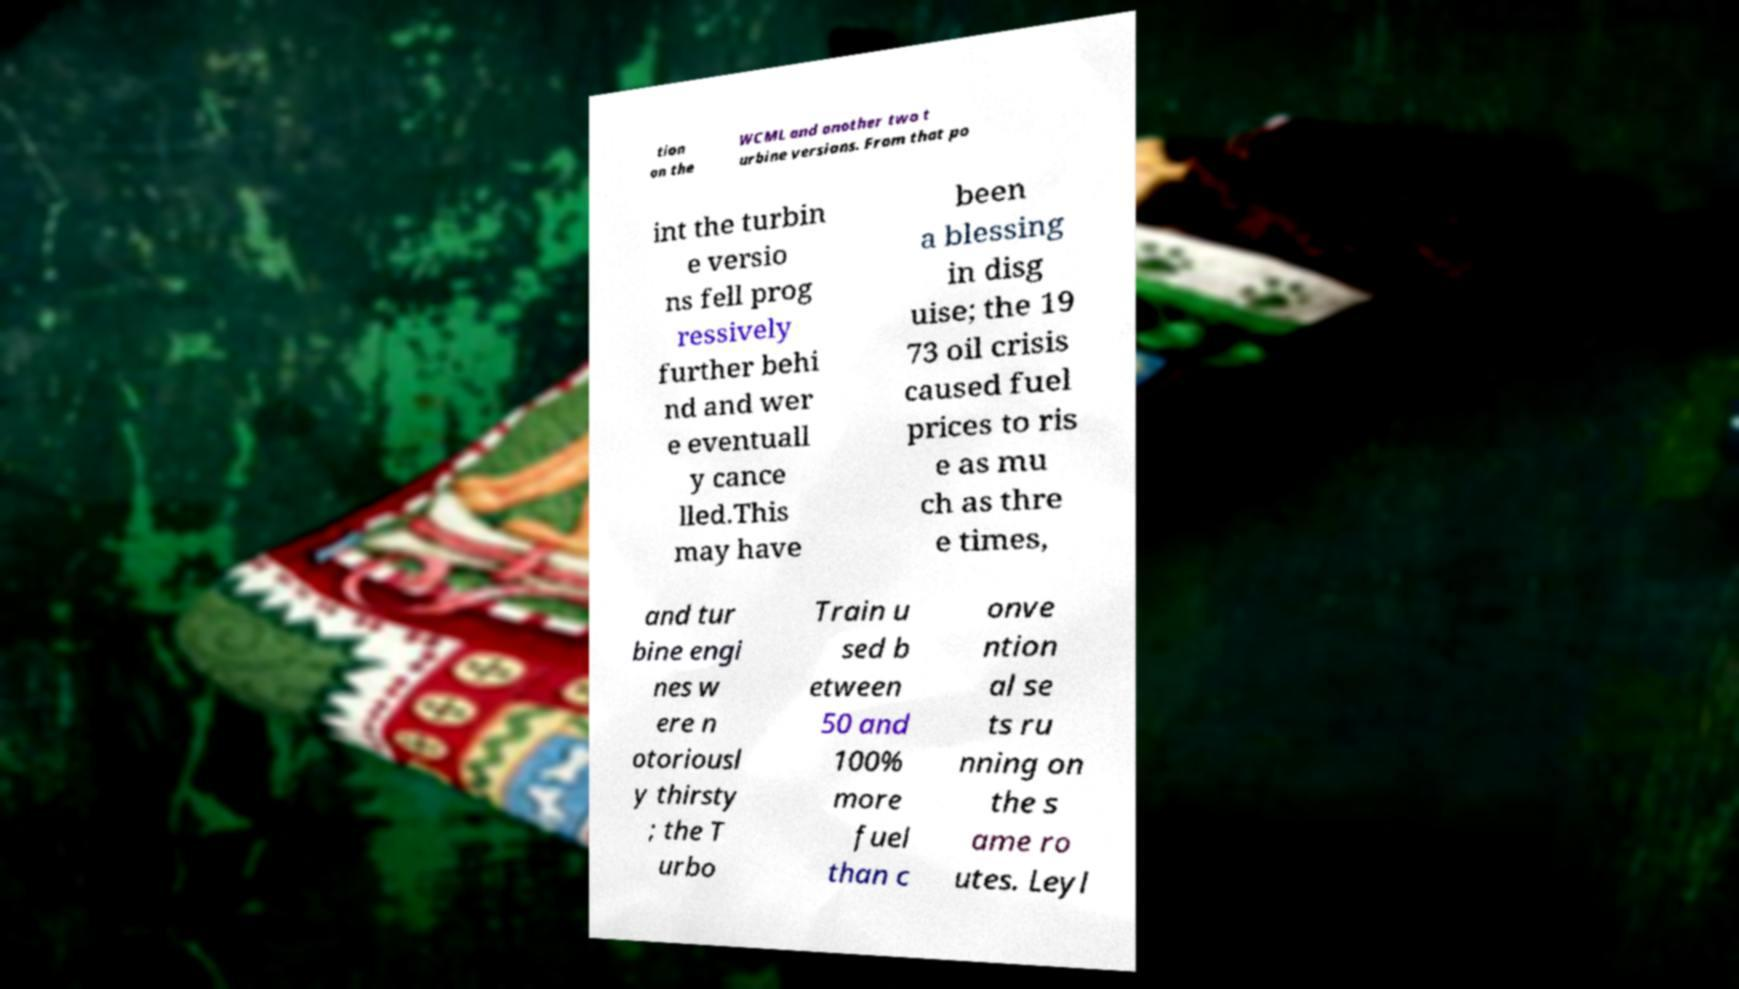What messages or text are displayed in this image? I need them in a readable, typed format. tion on the WCML and another two t urbine versions. From that po int the turbin e versio ns fell prog ressively further behi nd and wer e eventuall y cance lled.This may have been a blessing in disg uise; the 19 73 oil crisis caused fuel prices to ris e as mu ch as thre e times, and tur bine engi nes w ere n otoriousl y thirsty ; the T urbo Train u sed b etween 50 and 100% more fuel than c onve ntion al se ts ru nning on the s ame ro utes. Leyl 